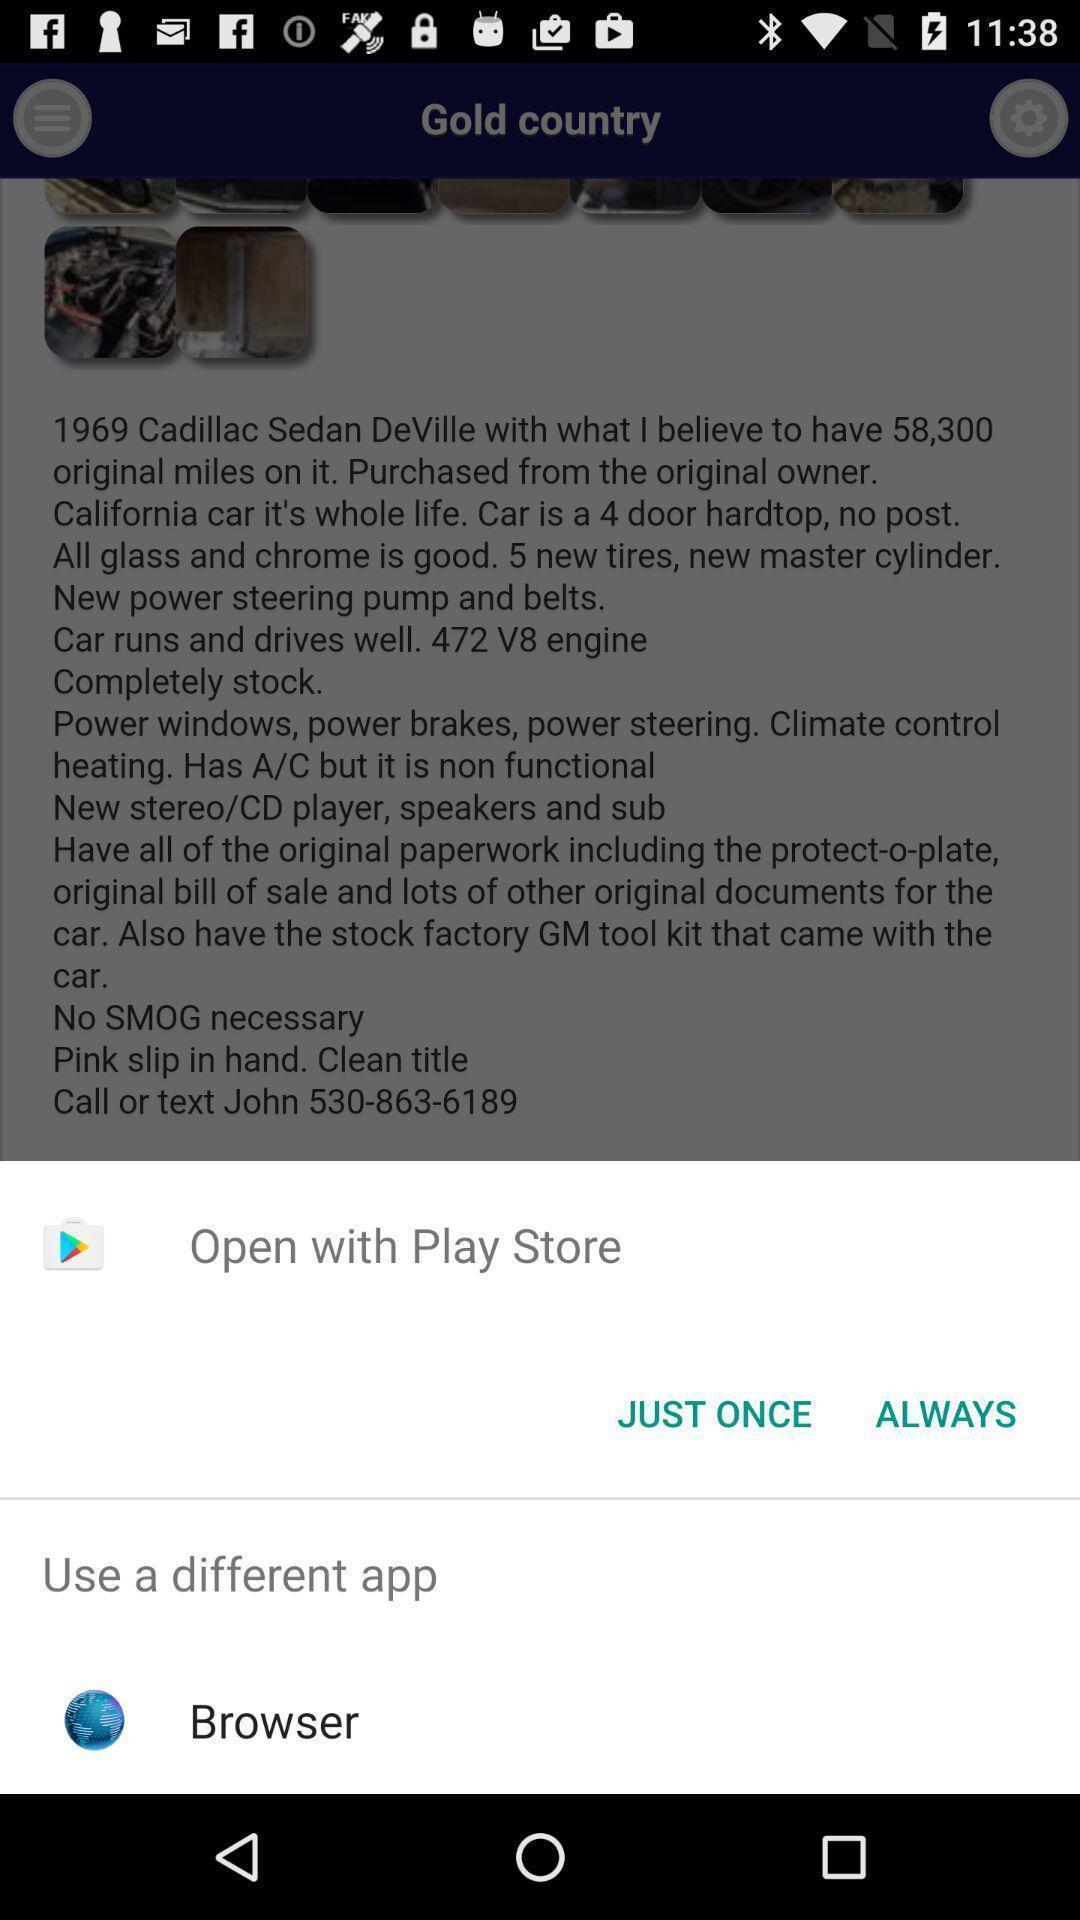Describe the visual elements of this screenshot. Pop-up with options to open from. 